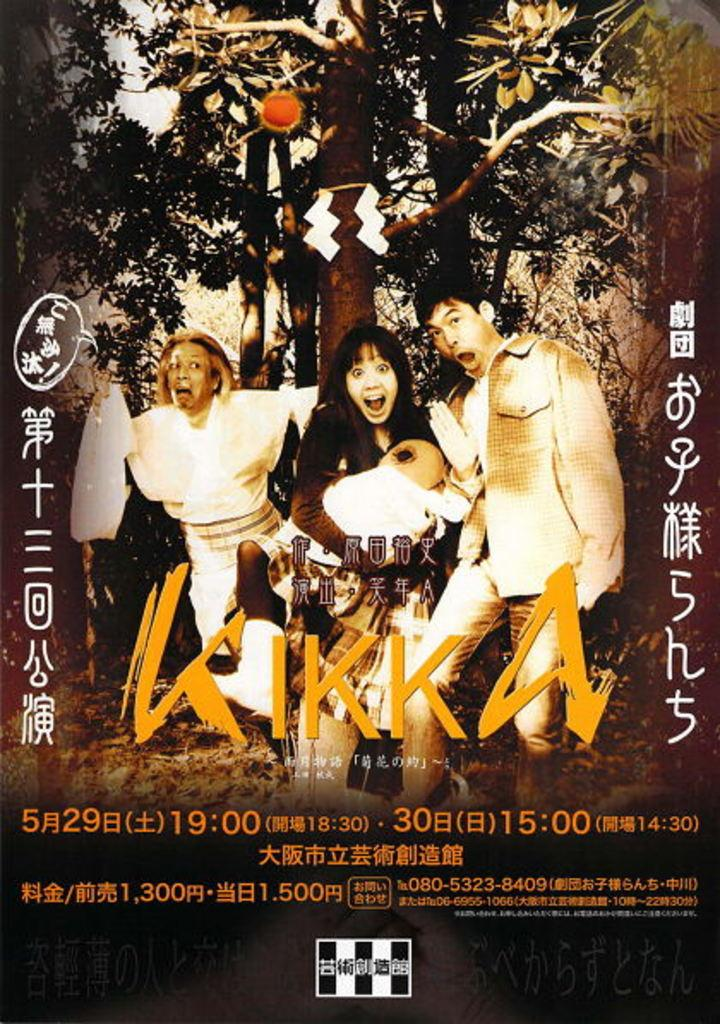What is the main subject of the image? There is an advertisement in the image. How many jars are visible in the advertisement? There is no jar visible in the image, as the main subject is an advertisement. What type of cactus is featured in the advertisement? There is no cactus present in the image, as the main subject is an advertisement. 